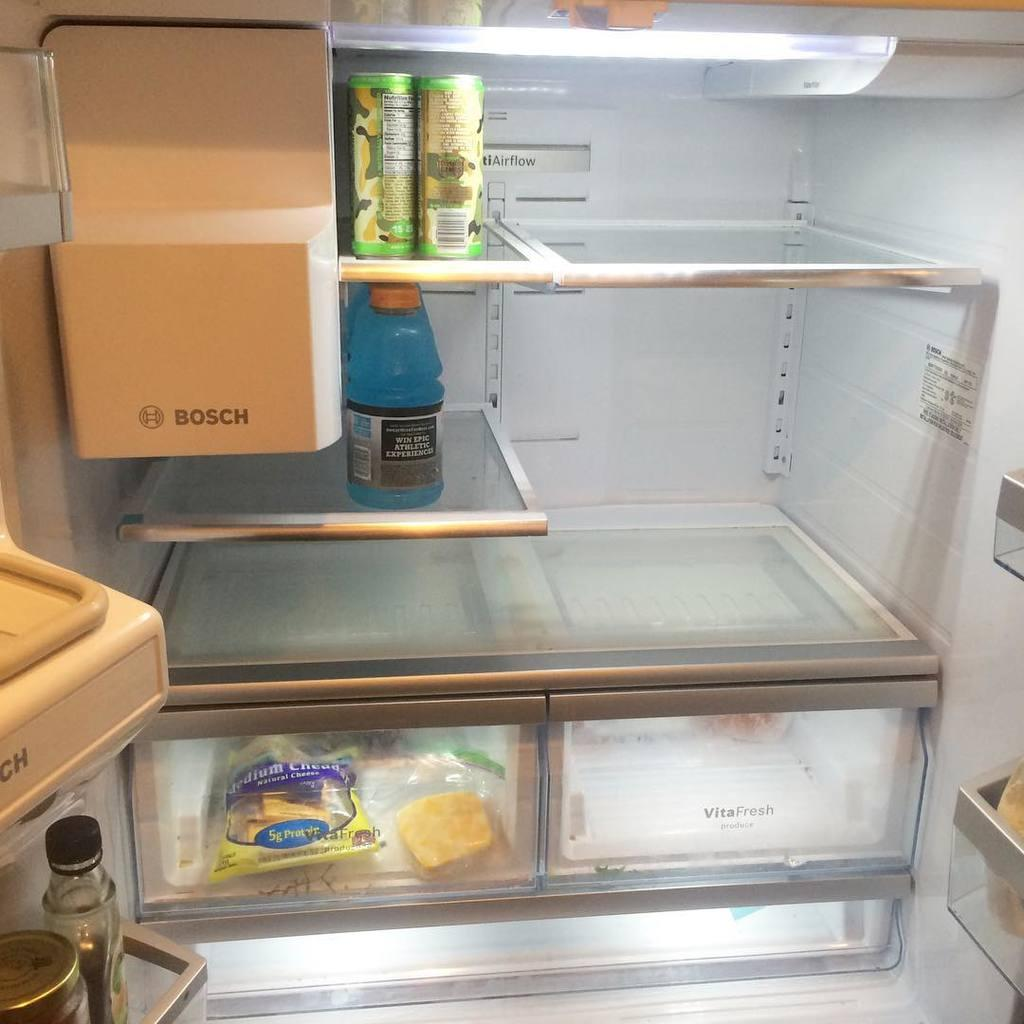What is the main subject of the image? The image shows the inner part of a fridge. Can you describe any specific items visible in the fridge? There is a bottle on a rack in the fridge. What type of profit can be seen in the image? There is no profit visible in the image, as it shows the inner part of a fridge with a bottle on a rack. 